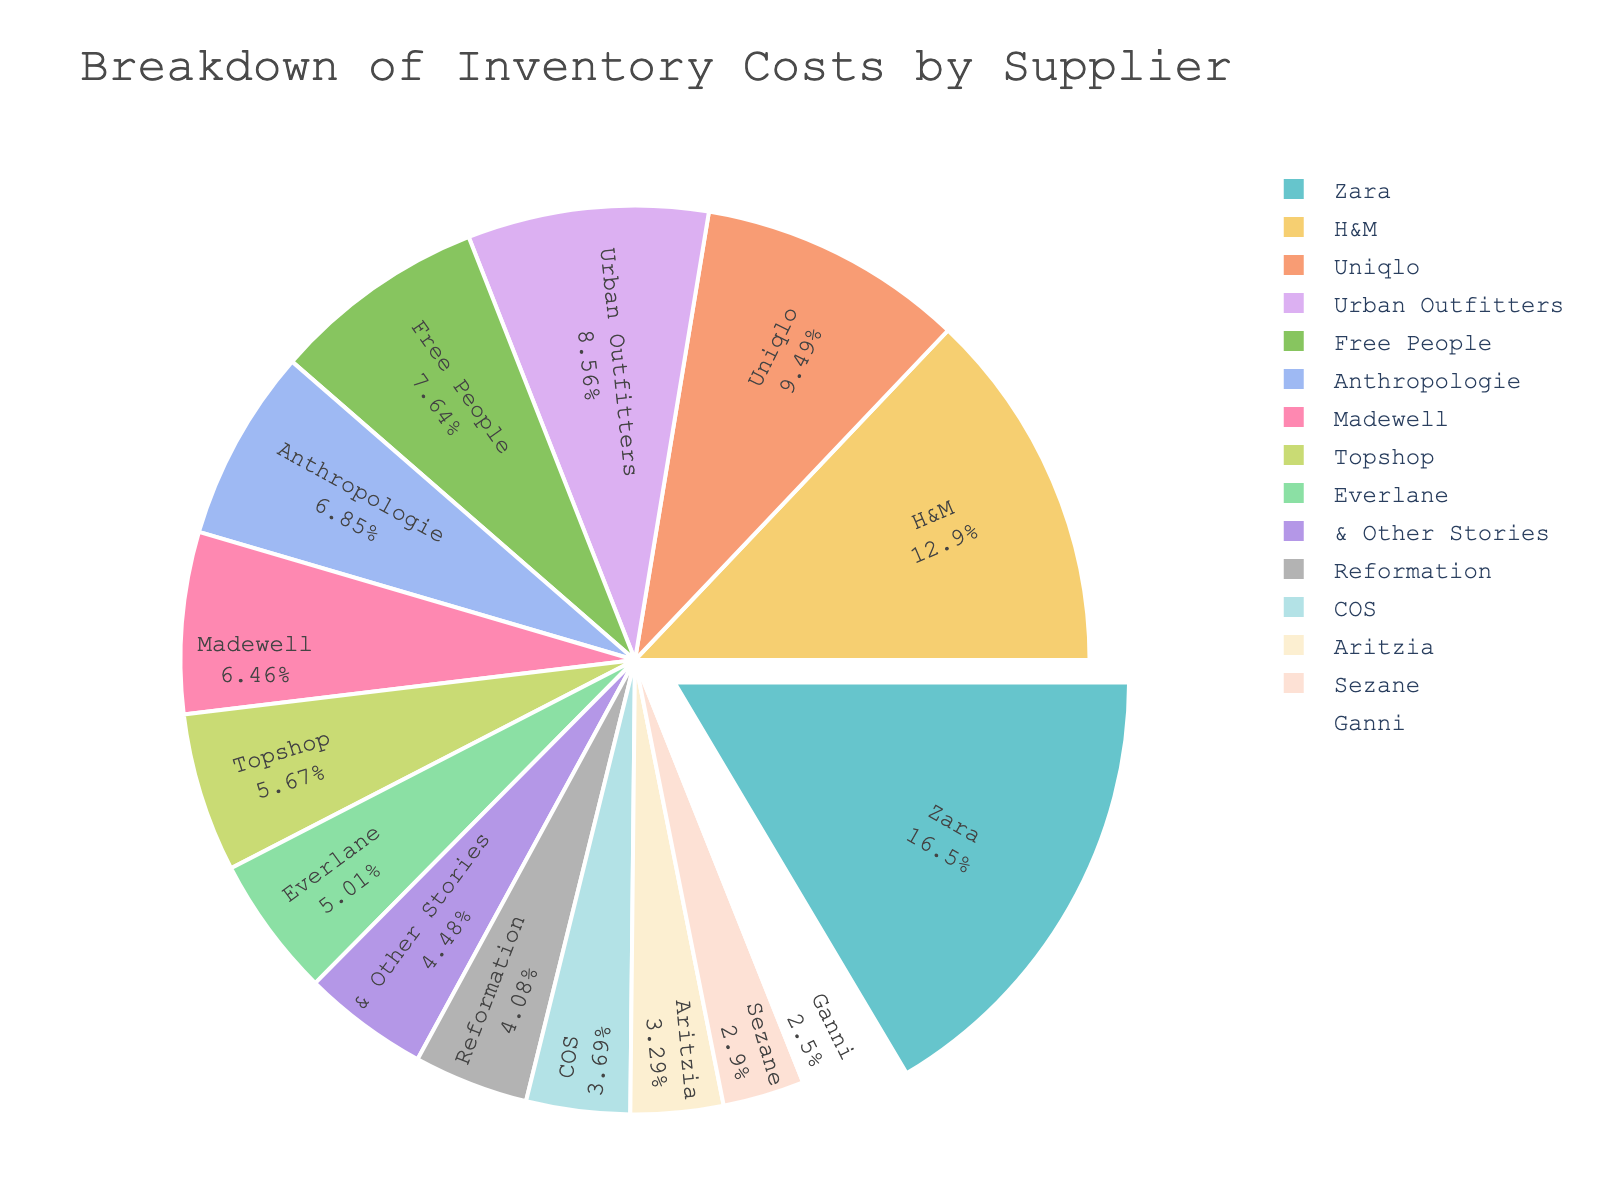What percentage of the total inventory cost does Zara contribute? To find Zara's contribution percentage, look at its segment in the pie chart, which provides the percentage directly in the label placed inside the segment representing Zara.
Answer: 16% Which supplier has the lowest contribution to the total inventory cost? From the pie chart, identify the segment with the smallest percentage label. This corresponds to the supplier with the lowest cost contribution.
Answer: Ganni Is H&M's cost contribution greater than Uniqlo's? Compare the percentage labels inside the segments for H&M and Uniqlo. If H&M's percentage is higher than Uniqlo's, then its cost contribution is greater.
Answer: Yes What is the approximate difference in cost contribution percentages between Uniqlo and Madewell? Subtract the percentage label for Madewell from that of Uniqlo to find the difference in their cost contributions.
Answer: 7% (12% - 5%) If you combine the inventory costs of Urban Outfitters and Free People, what percentage of the total does it represent? Add the percentages of Urban Outfitters and Free People from the pie chart and find the sum.
Answer: 13% (8% + 5%) Rank the top three suppliers in terms of their inventory cost contribution. Identify the three largest percentage segments in the pie chart which represent the suppliers with the highest contributions.
Answer: Zara, H&M, Uniqlo Which suppliers contribute more than 10% to the total inventory cost? Locate all segments in the pie chart with percentage labels greater than 10%. These labels identify the suppliers that contribute more than 10%.
Answer: Zara, H&M, Uniqlo How does the contribution of Topshop compare to that of Anthropologie? Compare the percentage labels for Topshop and Anthropologie. Determine if Topshop's percentage is higher, lower, or equal to Anthropologie's.
Answer: Lower What is the cumulative percentage contribution of COS, Aritzia, Sezane, and Ganni? Sum the percentage labels of COS, Aritzia, Sezane, and Ganni from the pie chart for their combined contribution.
Answer: 15% (4% + 3% + 3% + 2%) Which two suppliers have the closest inventory cost contributions, and what are those percentages? Inspect the segments for suppliers with adjacent or very close percentage labels in the pie chart. Identify these suppliers and their percentage contributions.
Answer: COS and Aritzia, 4% and 3% respectively 